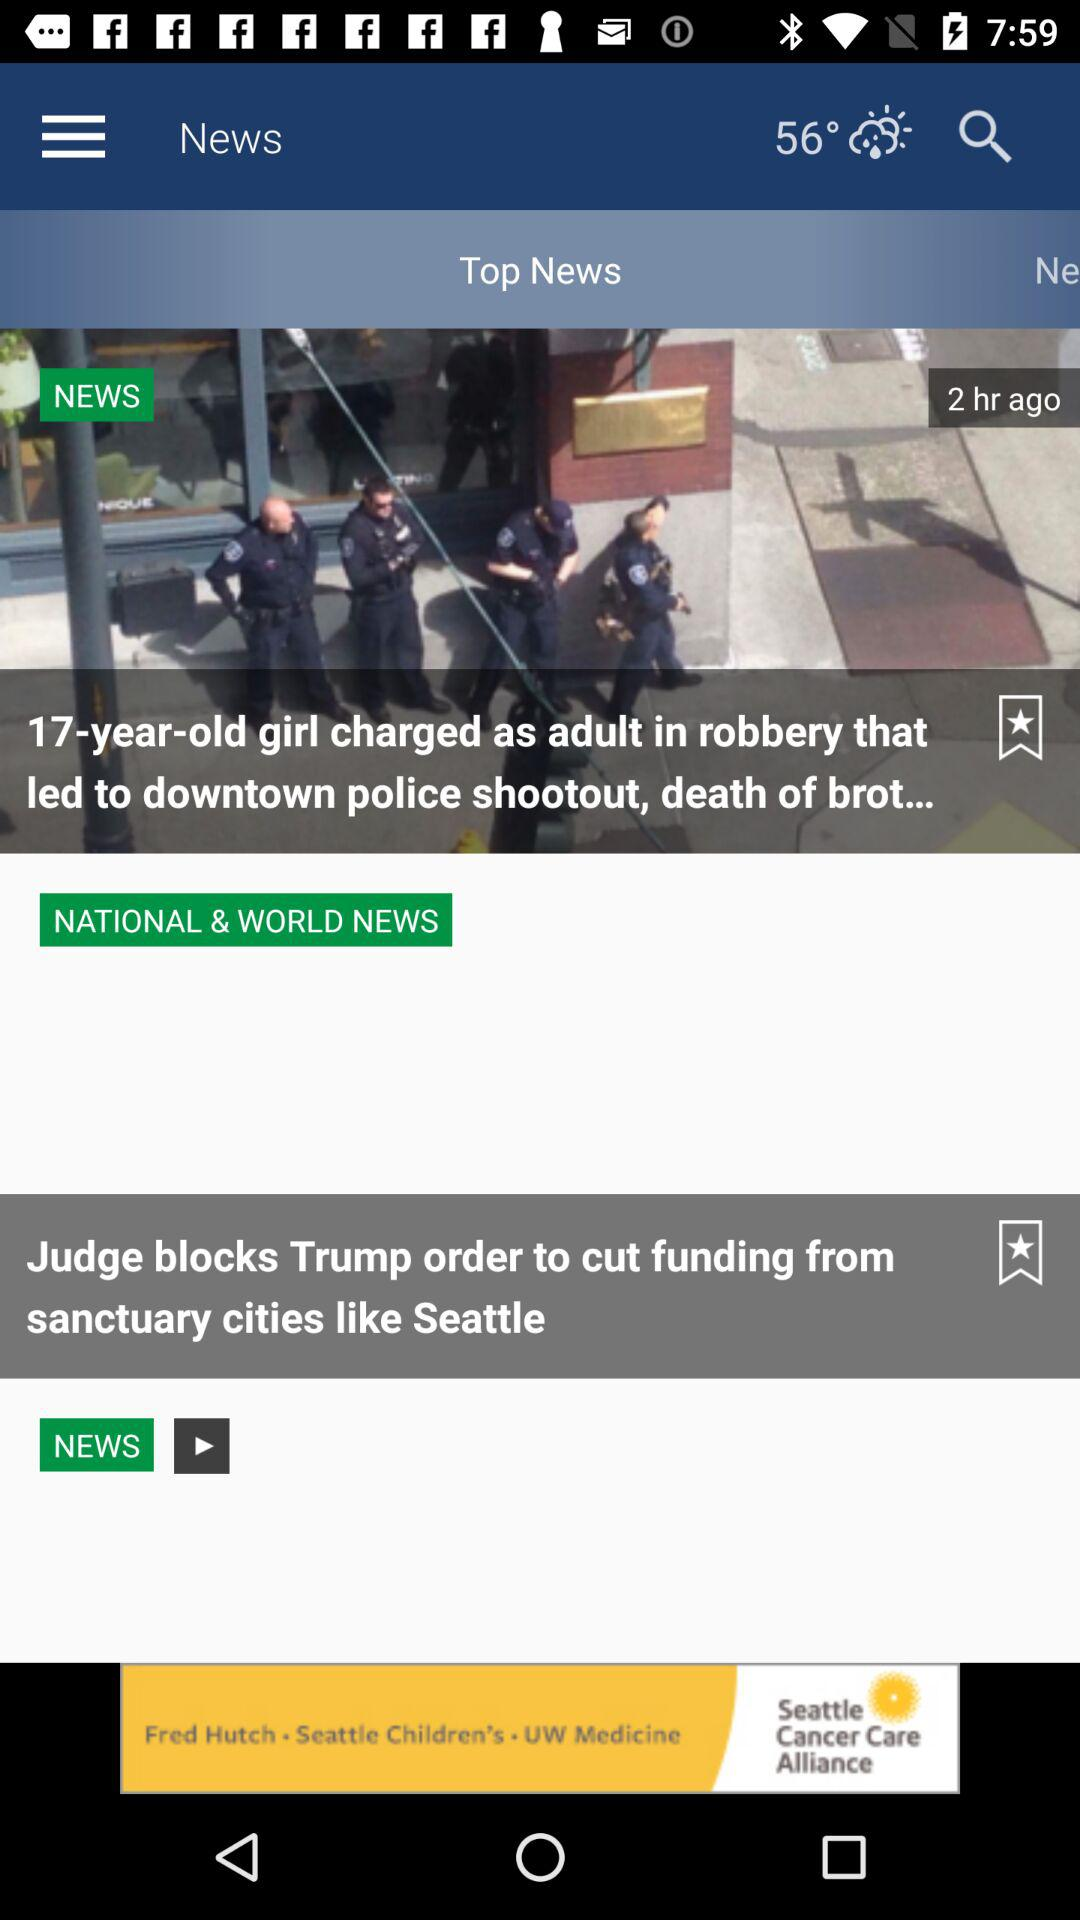How many hours ago the news "17-year-old girl charged as adult in robbery that led to downtown police shootout, death of brot..." was updated? The news was updated 2 hours ago. 